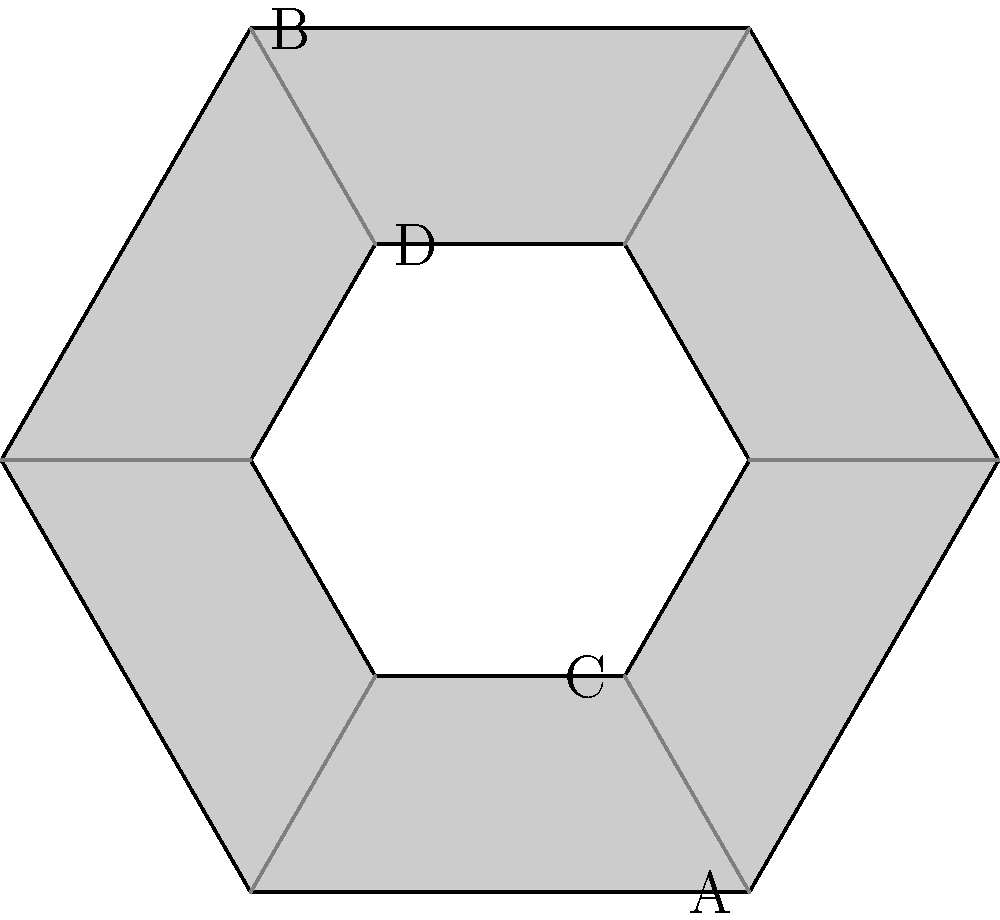In this geometric tattoo design based on a hexagon, which line segment would you need to add to create perfect symmetry across the vertical axis? To determine the line segment needed for perfect symmetry across the vertical axis, let's follow these steps:

1. Identify the vertical axis: It passes through points A and B, bisecting the hexagon.

2. Examine existing elements:
   - The outer and inner hexagons are already symmetrical.
   - There are six lines connecting the vertices of the outer and inner hexagons.

3. Check for symmetry of connecting lines:
   - Lines AC and BD are already symmetrical across the vertical axis.
   - The four diagonal lines are not symmetrical.

4. Identify missing symmetry:
   - The top-left diagonal line needs a corresponding line on the top-right.
   - The bottom-right diagonal line needs a corresponding line on the bottom-left.

5. Choose the missing segment:
   - Adding either the top-right or bottom-left diagonal would create symmetry.
   - The question asks for one line segment, so either would be correct.

6. For consistency with graffiti-inspired style:
   - Adding the top-right diagonal would create a more balanced, complete look.

Therefore, the line segment connecting the top-right vertex of the outer hexagon to the top-right vertex of the inner hexagon would create perfect symmetry across the vertical axis.
Answer: Top-right diagonal 